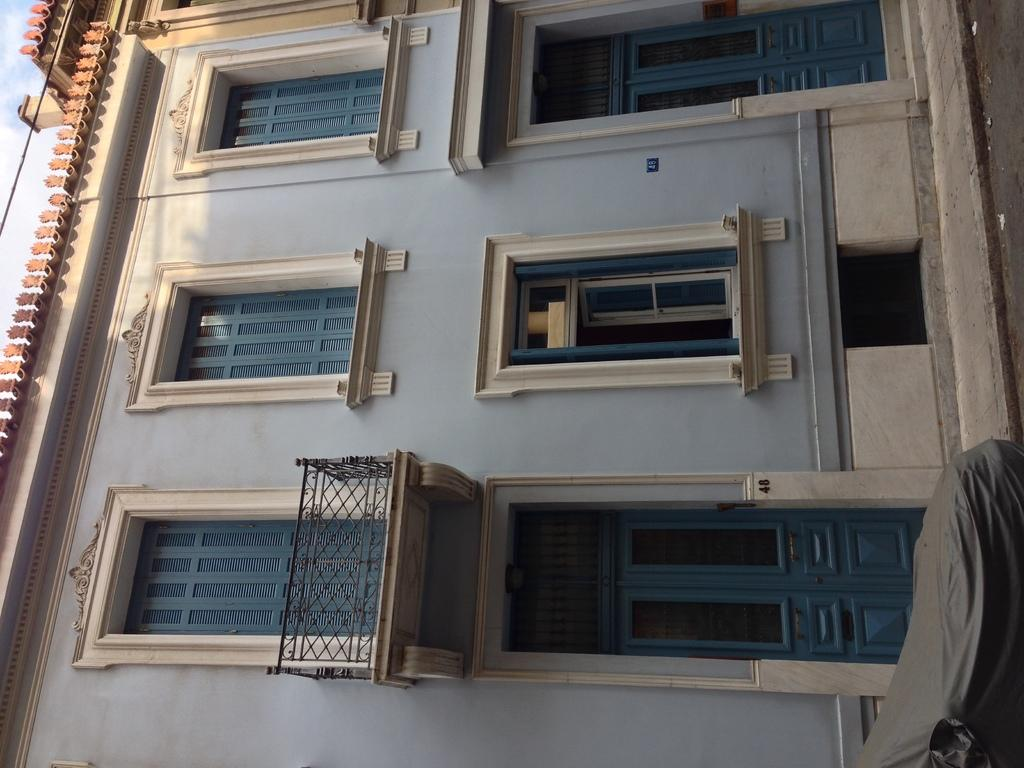What type of structure is present in the image? There is a building in the image. What part of the sky can be seen in the image? The sky is visible in the top left of the image. What is located in the bottom right of the image? There is a cloth in the bottom right of the image. What type of pathway is present on the right side of the image? There is a road on the right side of the image. What type of sea creature can be seen swimming near the building in the image? There is no sea creature present in the image, as it does not depict a body of water. 